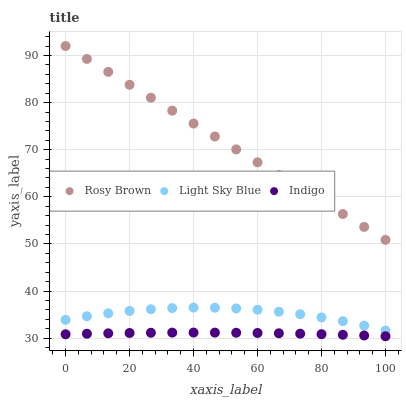Does Indigo have the minimum area under the curve?
Answer yes or no. Yes. Does Rosy Brown have the maximum area under the curve?
Answer yes or no. Yes. Does Light Sky Blue have the minimum area under the curve?
Answer yes or no. No. Does Light Sky Blue have the maximum area under the curve?
Answer yes or no. No. Is Rosy Brown the smoothest?
Answer yes or no. Yes. Is Light Sky Blue the roughest?
Answer yes or no. Yes. Is Indigo the smoothest?
Answer yes or no. No. Is Indigo the roughest?
Answer yes or no. No. Does Indigo have the lowest value?
Answer yes or no. Yes. Does Light Sky Blue have the lowest value?
Answer yes or no. No. Does Rosy Brown have the highest value?
Answer yes or no. Yes. Does Light Sky Blue have the highest value?
Answer yes or no. No. Is Light Sky Blue less than Rosy Brown?
Answer yes or no. Yes. Is Rosy Brown greater than Indigo?
Answer yes or no. Yes. Does Light Sky Blue intersect Rosy Brown?
Answer yes or no. No. 